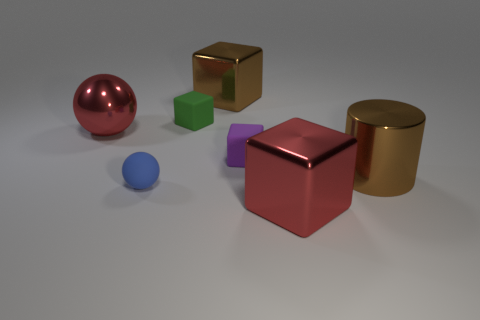Does the shiny sphere have the same color as the tiny thing behind the shiny sphere?
Keep it short and to the point. No. Are there the same number of purple rubber blocks behind the tiny green matte cube and red shiny things that are in front of the brown metal cylinder?
Give a very brief answer. No. How many other objects are the same size as the red shiny block?
Keep it short and to the point. 3. What is the size of the shiny sphere?
Make the answer very short. Large. Does the small green cube have the same material as the blue thing that is in front of the big brown metal cylinder?
Your answer should be compact. Yes. Are there any tiny purple matte things of the same shape as the tiny blue rubber thing?
Keep it short and to the point. No. There is a blue sphere that is the same size as the purple cube; what is it made of?
Provide a short and direct response. Rubber. There is a red metallic object on the left side of the large brown metallic block; how big is it?
Your answer should be very brief. Large. Does the red metallic object to the right of the large ball have the same size as the ball that is in front of the red ball?
Make the answer very short. No. What number of small things have the same material as the cylinder?
Offer a terse response. 0. 